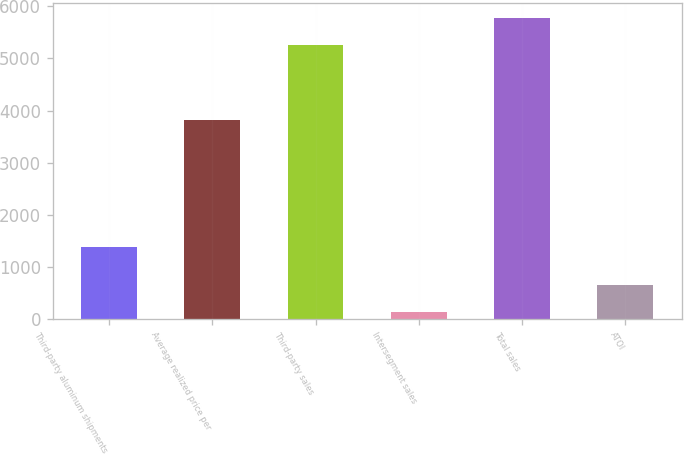Convert chart. <chart><loc_0><loc_0><loc_500><loc_500><bar_chart><fcel>Third-party aluminum shipments<fcel>Average realized price per<fcel>Third-party sales<fcel>Intersegment sales<fcel>Total sales<fcel>ATOI<nl><fcel>1375<fcel>3820<fcel>5253<fcel>125<fcel>5778.3<fcel>650.3<nl></chart> 